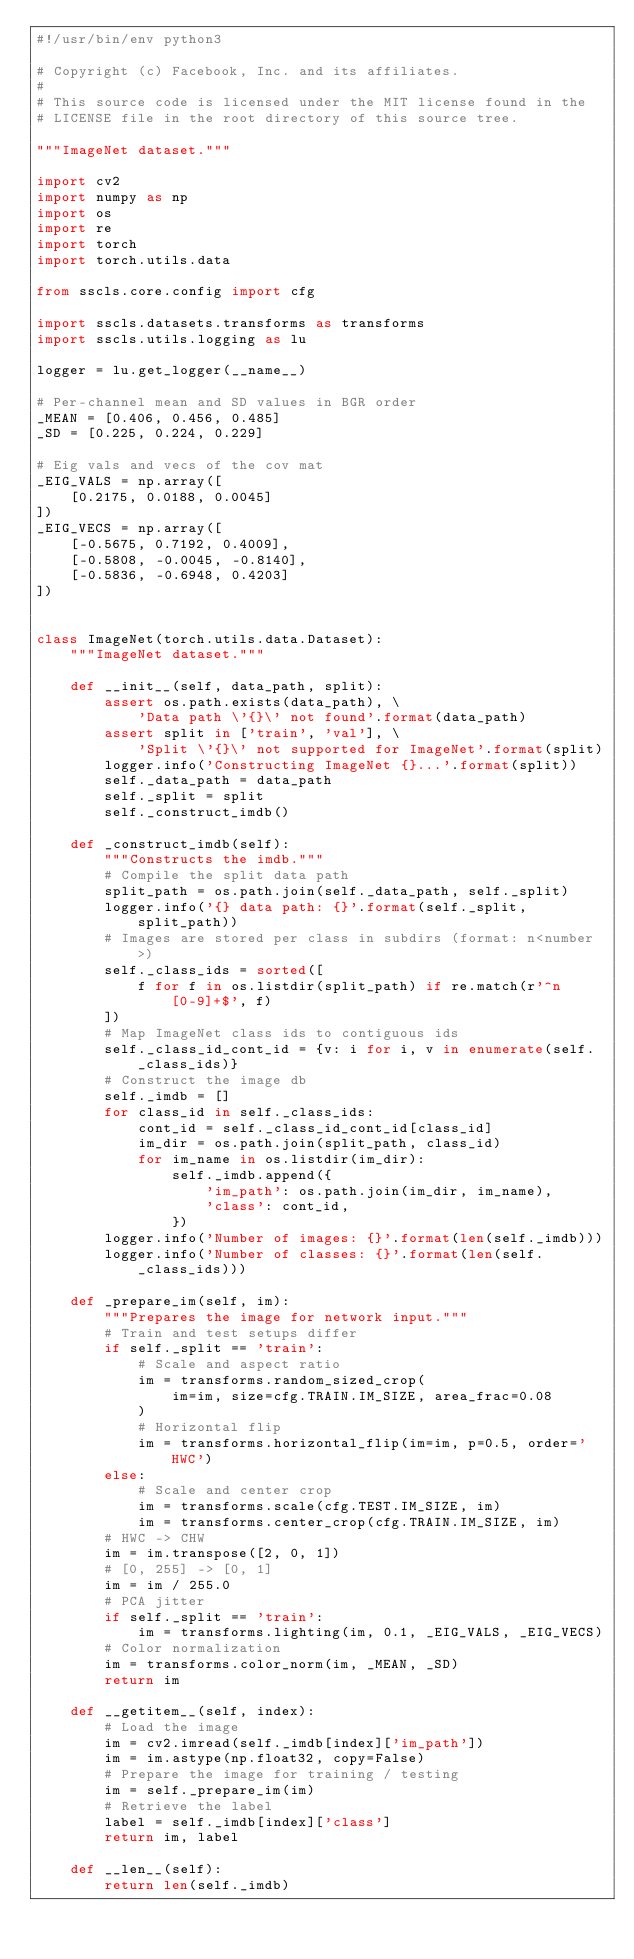Convert code to text. <code><loc_0><loc_0><loc_500><loc_500><_Python_>#!/usr/bin/env python3

# Copyright (c) Facebook, Inc. and its affiliates.
#
# This source code is licensed under the MIT license found in the
# LICENSE file in the root directory of this source tree.

"""ImageNet dataset."""

import cv2
import numpy as np
import os
import re
import torch
import torch.utils.data

from sscls.core.config import cfg

import sscls.datasets.transforms as transforms
import sscls.utils.logging as lu

logger = lu.get_logger(__name__)

# Per-channel mean and SD values in BGR order
_MEAN = [0.406, 0.456, 0.485]
_SD = [0.225, 0.224, 0.229]

# Eig vals and vecs of the cov mat
_EIG_VALS = np.array([
    [0.2175, 0.0188, 0.0045]
])
_EIG_VECS = np.array([
    [-0.5675, 0.7192, 0.4009],
    [-0.5808, -0.0045, -0.8140],
    [-0.5836, -0.6948, 0.4203]
])


class ImageNet(torch.utils.data.Dataset):
    """ImageNet dataset."""

    def __init__(self, data_path, split):
        assert os.path.exists(data_path), \
            'Data path \'{}\' not found'.format(data_path)
        assert split in ['train', 'val'], \
            'Split \'{}\' not supported for ImageNet'.format(split)
        logger.info('Constructing ImageNet {}...'.format(split))
        self._data_path = data_path
        self._split = split
        self._construct_imdb()

    def _construct_imdb(self):
        """Constructs the imdb."""
        # Compile the split data path
        split_path = os.path.join(self._data_path, self._split)
        logger.info('{} data path: {}'.format(self._split, split_path))
        # Images are stored per class in subdirs (format: n<number>)
        self._class_ids = sorted([
            f for f in os.listdir(split_path) if re.match(r'^n[0-9]+$', f)
        ])
        # Map ImageNet class ids to contiguous ids
        self._class_id_cont_id = {v: i for i, v in enumerate(self._class_ids)}
        # Construct the image db
        self._imdb = []
        for class_id in self._class_ids:
            cont_id = self._class_id_cont_id[class_id]
            im_dir = os.path.join(split_path, class_id)
            for im_name in os.listdir(im_dir):
                self._imdb.append({
                    'im_path': os.path.join(im_dir, im_name),
                    'class': cont_id,
                })
        logger.info('Number of images: {}'.format(len(self._imdb)))
        logger.info('Number of classes: {}'.format(len(self._class_ids)))

    def _prepare_im(self, im):
        """Prepares the image for network input."""
        # Train and test setups differ
        if self._split == 'train':
            # Scale and aspect ratio
            im = transforms.random_sized_crop(
                im=im, size=cfg.TRAIN.IM_SIZE, area_frac=0.08
            )
            # Horizontal flip
            im = transforms.horizontal_flip(im=im, p=0.5, order='HWC')
        else:
            # Scale and center crop
            im = transforms.scale(cfg.TEST.IM_SIZE, im)
            im = transforms.center_crop(cfg.TRAIN.IM_SIZE, im)
        # HWC -> CHW
        im = im.transpose([2, 0, 1])
        # [0, 255] -> [0, 1]
        im = im / 255.0
        # PCA jitter
        if self._split == 'train':
            im = transforms.lighting(im, 0.1, _EIG_VALS, _EIG_VECS)
        # Color normalization
        im = transforms.color_norm(im, _MEAN, _SD)
        return im

    def __getitem__(self, index):
        # Load the image
        im = cv2.imread(self._imdb[index]['im_path'])
        im = im.astype(np.float32, copy=False)
        # Prepare the image for training / testing
        im = self._prepare_im(im)
        # Retrieve the label
        label = self._imdb[index]['class']
        return im, label

    def __len__(self):
        return len(self._imdb)
</code> 